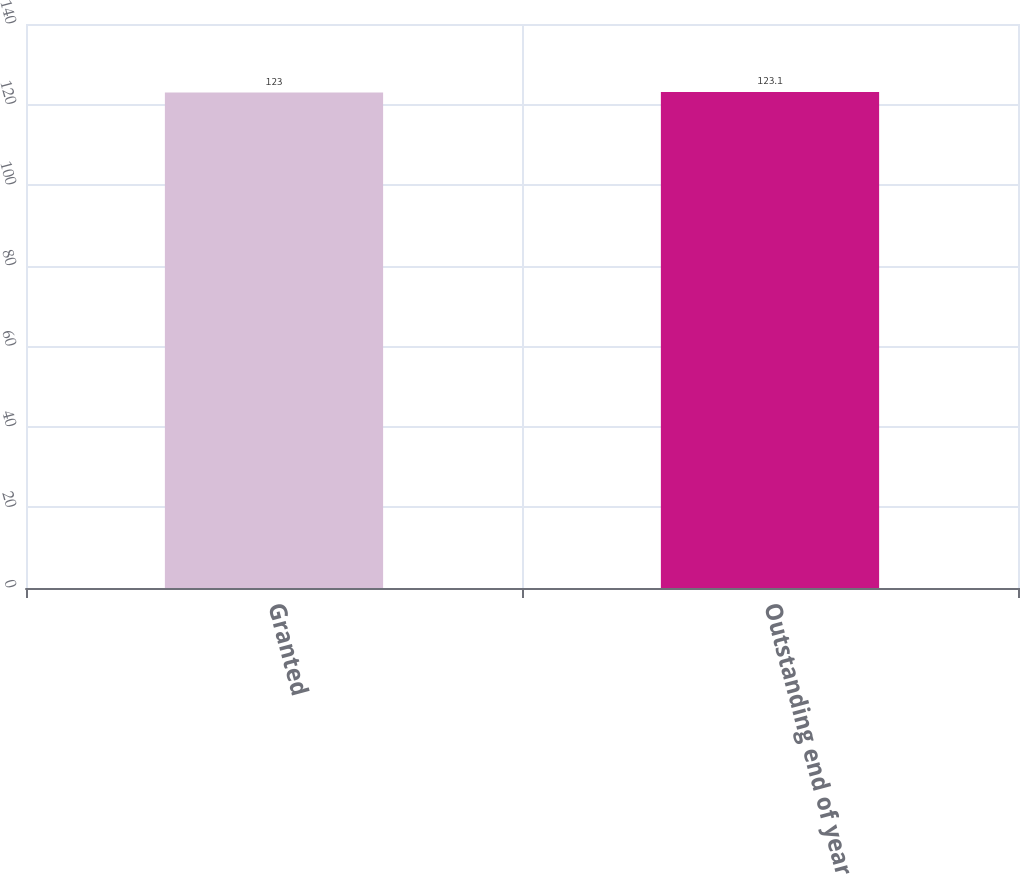Convert chart to OTSL. <chart><loc_0><loc_0><loc_500><loc_500><bar_chart><fcel>Granted<fcel>Outstanding end of year<nl><fcel>123<fcel>123.1<nl></chart> 